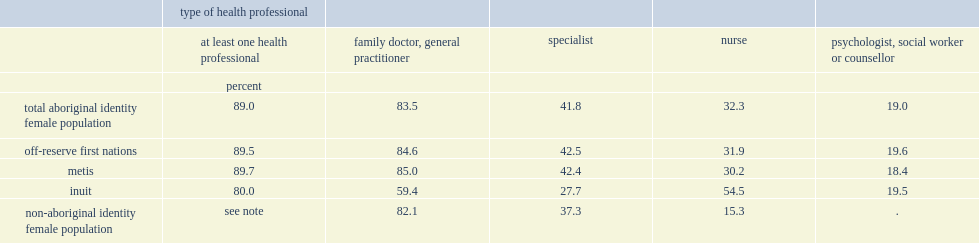Among inuit women, how many percent had seen or talked to a family doctor? 59.4. Among inuit women, how many percent had seen or talked to a nurse? 54.5. How many percent of non-aboriginal women aged 15 and over had consulted a family doctor? 82.1. How many percent of non-aboriginal women aged 15 and over had consulted a nurse? 15.3. 